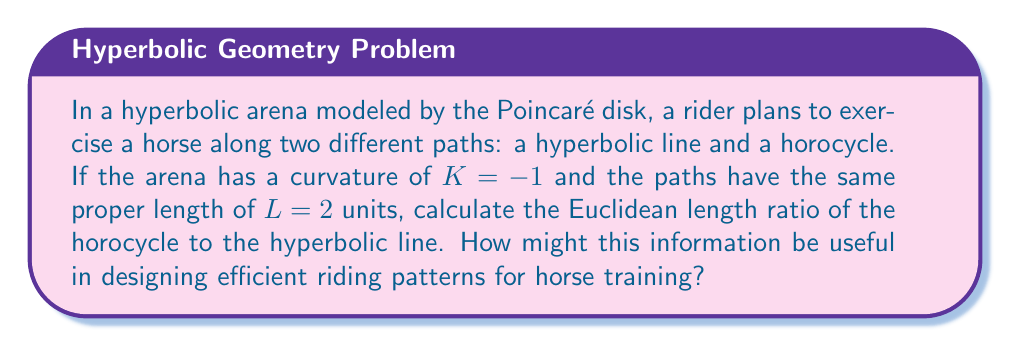What is the answer to this math problem? Let's approach this step-by-step:

1) In the Poincaré disk model with curvature $K = -1$, we can use the following formulas:

   For a hyperbolic line: $L = 2 \tanh^{-1}(r)$
   For a horocycle: $L = \frac{1-r^2}{r}$

   Where $L$ is the proper length and $r$ is the Euclidean radius.

2) For the hyperbolic line:
   $2 = 2 \tanh^{-1}(r_1)$
   $1 = \tanh^{-1}(r_1)$
   $r_1 = \tanh(1) \approx 0.7616$

3) For the horocycle:
   $2 = \frac{1-r_2^2}{r_2}$
   $2r_2 = 1-r_2^2$
   $r_2^2 + 2r_2 - 1 = 0$
   Solving this quadratic equation:
   $r_2 = \sqrt{2} - 1 \approx 0.4142$

4) The Euclidean length of a circular arc is given by $2\pi r\theta$, where $\theta$ is the central angle in radians.

5) For the hyperbolic line, $\theta_1 = 2 \sin^{-1}(r_1) \approx 1.7222$
   Euclidean length of hyperbolic line = $2\pi r_1 \theta_1 \approx 8.2682$

6) For the horocycle, $\theta_2 = 2\pi$
   Euclidean length of horocycle = $2\pi r_2 \approx 2.6054$

7) Ratio of Euclidean lengths (horocycle to hyperbolic line) = $\frac{2.6054}{8.2682} \approx 0.3151$

This ratio indicates that the horocycle has a shorter Euclidean length despite having the same proper length as the hyperbolic line. For horse training, this means that riding along horocycles could provide more concentrated exercise in a smaller Euclidean area, potentially increasing efficiency in arena usage and allowing for more repetitions in a given timeframe.
Answer: $0.3151$ 